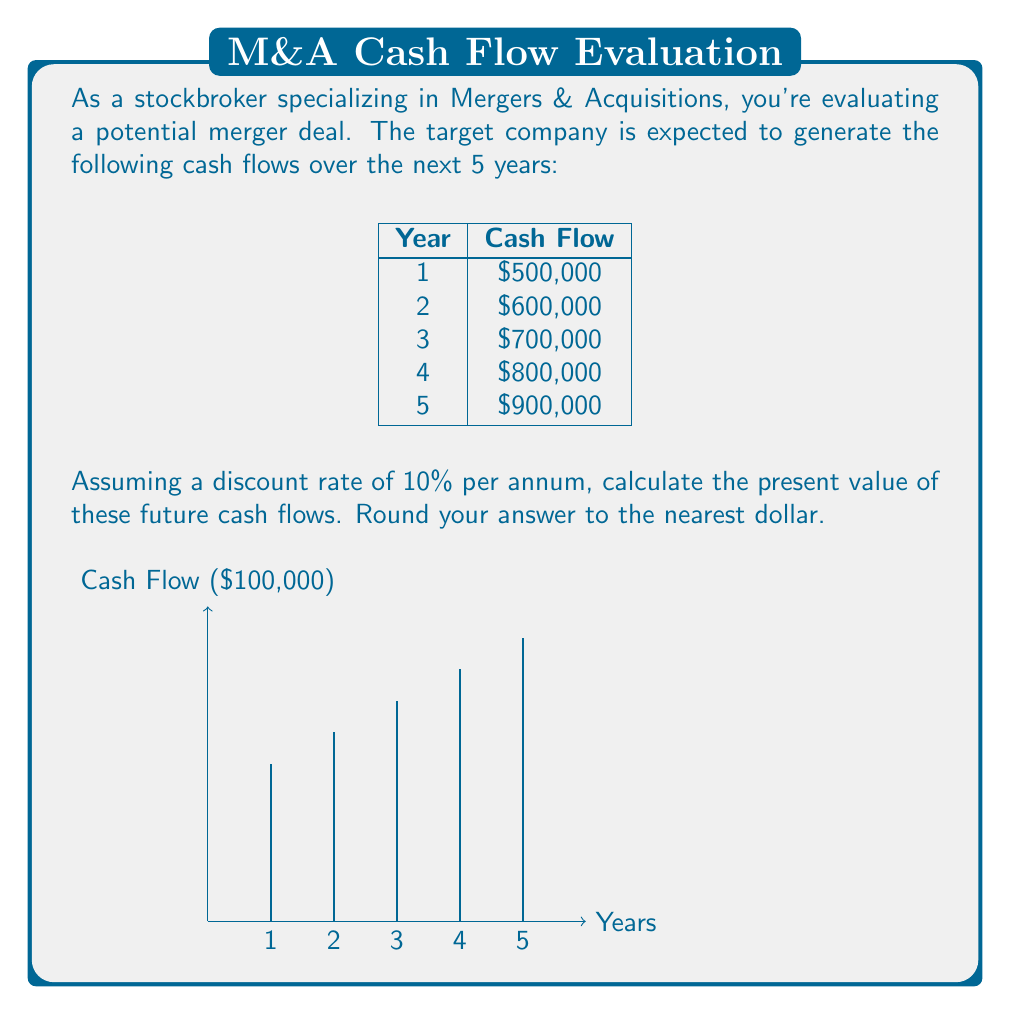Can you solve this math problem? To calculate the present value of future cash flows, we need to discount each cash flow back to the present using the given discount rate. The formula for present value is:

$$ PV = \frac{CF_t}{(1+r)^t} $$

Where:
$PV$ = Present Value
$CF_t$ = Cash Flow at time t
$r$ = Discount rate
$t$ = Time period

Let's calculate the present value for each year:

Year 1: $PV_1 = \frac{500,000}{(1+0.10)^1} = 454,545.45$

Year 2: $PV_2 = \frac{600,000}{(1+0.10)^2} = 495,867.77$

Year 3: $PV_3 = \frac{700,000}{(1+0.10)^3} = 526,283.63$

Year 4: $PV_4 = \frac{800,000}{(1+0.10)^4} = 547,009.74$

Year 5: $PV_5 = \frac{900,000}{(1+0.10)^5} = 559,017.90$

Now, we sum up all these present values:

$$ Total PV = 454,545.45 + 495,867.77 + 526,283.63 + 547,009.74 + 559,017.90 $$
$$ Total PV = 2,582,724.49 $$

Rounding to the nearest dollar, we get $2,582,724.
Answer: $2,582,724 